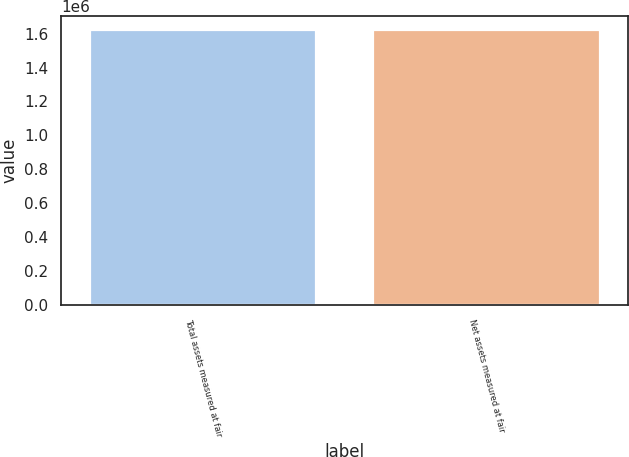Convert chart. <chart><loc_0><loc_0><loc_500><loc_500><bar_chart><fcel>Total assets measured at fair<fcel>Net assets measured at fair<nl><fcel>1.62346e+06<fcel>1.62198e+06<nl></chart> 